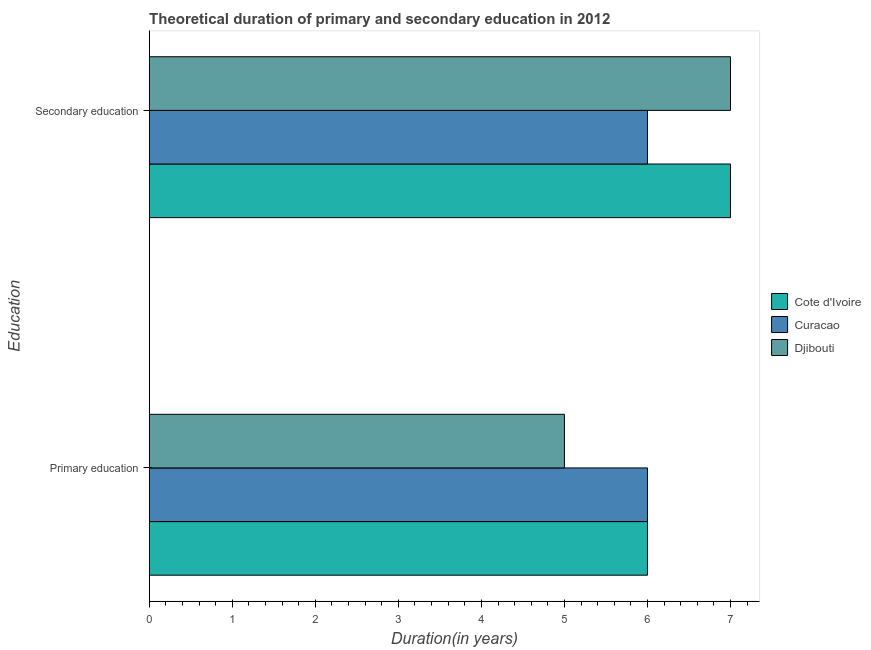How many different coloured bars are there?
Ensure brevity in your answer.  3. How many groups of bars are there?
Your response must be concise. 2. Are the number of bars per tick equal to the number of legend labels?
Make the answer very short. Yes. Are the number of bars on each tick of the Y-axis equal?
Offer a very short reply. Yes. How many bars are there on the 1st tick from the top?
Keep it short and to the point. 3. What is the duration of secondary education in Cote d'Ivoire?
Ensure brevity in your answer.  7. In which country was the duration of secondary education maximum?
Your response must be concise. Cote d'Ivoire. In which country was the duration of secondary education minimum?
Provide a short and direct response. Curacao. What is the total duration of primary education in the graph?
Offer a terse response. 17. What is the difference between the duration of primary education in Curacao and that in Djibouti?
Offer a terse response. 1. What is the difference between the duration of secondary education in Djibouti and the duration of primary education in Cote d'Ivoire?
Offer a terse response. 1. What is the average duration of secondary education per country?
Keep it short and to the point. 6.67. What is the difference between the duration of primary education and duration of secondary education in Djibouti?
Provide a succinct answer. -2. In how many countries, is the duration of primary education greater than 4 years?
Offer a very short reply. 3. What is the ratio of the duration of secondary education in Curacao to that in Cote d'Ivoire?
Offer a terse response. 0.86. In how many countries, is the duration of secondary education greater than the average duration of secondary education taken over all countries?
Provide a short and direct response. 2. What does the 3rd bar from the top in Secondary education represents?
Your response must be concise. Cote d'Ivoire. What does the 1st bar from the bottom in Secondary education represents?
Your answer should be very brief. Cote d'Ivoire. Are all the bars in the graph horizontal?
Provide a short and direct response. Yes. What is the difference between two consecutive major ticks on the X-axis?
Offer a very short reply. 1. Are the values on the major ticks of X-axis written in scientific E-notation?
Make the answer very short. No. Does the graph contain any zero values?
Your response must be concise. No. Does the graph contain grids?
Ensure brevity in your answer.  No. How many legend labels are there?
Keep it short and to the point. 3. How are the legend labels stacked?
Offer a terse response. Vertical. What is the title of the graph?
Your answer should be very brief. Theoretical duration of primary and secondary education in 2012. What is the label or title of the X-axis?
Provide a succinct answer. Duration(in years). What is the label or title of the Y-axis?
Offer a terse response. Education. What is the Duration(in years) in Curacao in Secondary education?
Your response must be concise. 6. Across all Education, what is the minimum Duration(in years) of Cote d'Ivoire?
Ensure brevity in your answer.  6. What is the total Duration(in years) of Curacao in the graph?
Your answer should be very brief. 12. What is the difference between the Duration(in years) in Cote d'Ivoire in Primary education and that in Secondary education?
Your answer should be very brief. -1. What is the difference between the Duration(in years) of Curacao in Primary education and that in Secondary education?
Your answer should be very brief. 0. What is the difference between the Duration(in years) of Djibouti in Primary education and that in Secondary education?
Offer a terse response. -2. What is the difference between the Duration(in years) of Cote d'Ivoire in Primary education and the Duration(in years) of Curacao in Secondary education?
Offer a terse response. 0. What is the difference between the Duration(in years) of Curacao in Primary education and the Duration(in years) of Djibouti in Secondary education?
Give a very brief answer. -1. What is the difference between the Duration(in years) in Cote d'Ivoire and Duration(in years) in Curacao in Primary education?
Make the answer very short. 0. What is the difference between the Duration(in years) of Cote d'Ivoire and Duration(in years) of Djibouti in Primary education?
Your answer should be compact. 1. What is the difference between the Duration(in years) of Cote d'Ivoire and Duration(in years) of Curacao in Secondary education?
Your response must be concise. 1. What is the difference between the Duration(in years) of Curacao and Duration(in years) of Djibouti in Secondary education?
Your answer should be compact. -1. What is the ratio of the Duration(in years) of Cote d'Ivoire in Primary education to that in Secondary education?
Your response must be concise. 0.86. What is the ratio of the Duration(in years) of Curacao in Primary education to that in Secondary education?
Your answer should be compact. 1. What is the ratio of the Duration(in years) in Djibouti in Primary education to that in Secondary education?
Your answer should be very brief. 0.71. What is the difference between the highest and the second highest Duration(in years) of Curacao?
Ensure brevity in your answer.  0. What is the difference between the highest and the lowest Duration(in years) of Cote d'Ivoire?
Keep it short and to the point. 1. What is the difference between the highest and the lowest Duration(in years) of Curacao?
Your answer should be compact. 0. 